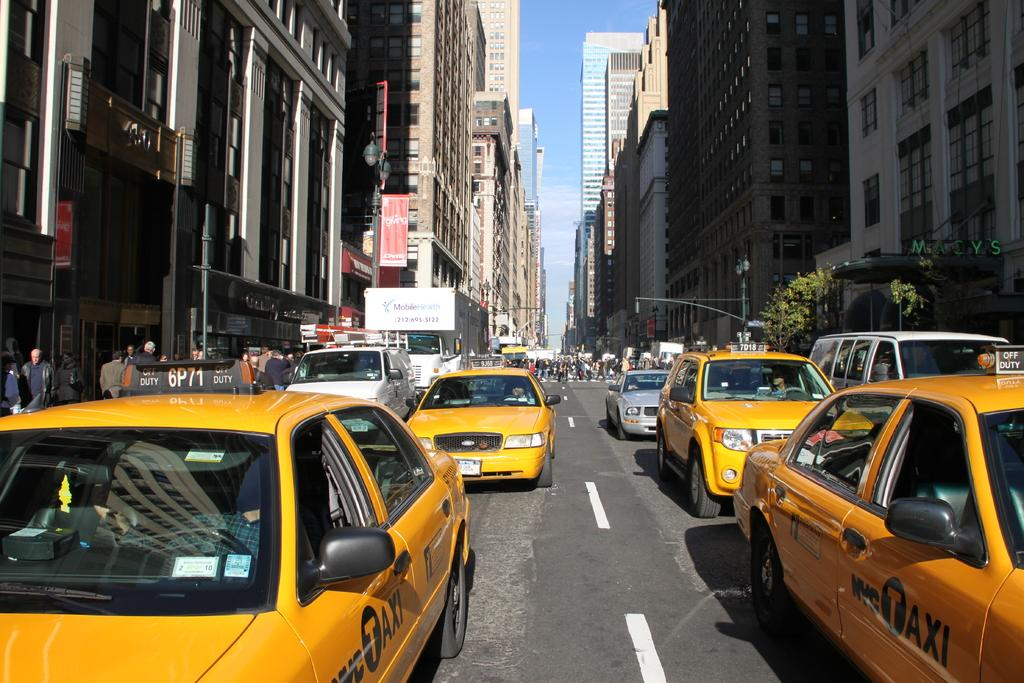<image>
Summarize the visual content of the image. A street in NY with multiple yellow NYC TAXIs. 